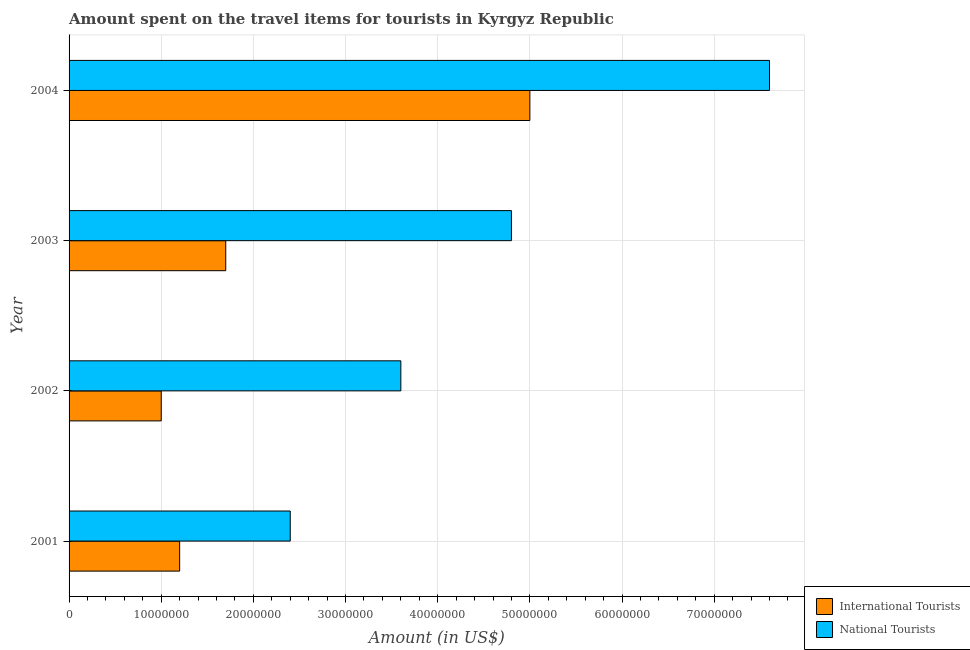How many different coloured bars are there?
Your answer should be compact. 2. How many groups of bars are there?
Keep it short and to the point. 4. Are the number of bars per tick equal to the number of legend labels?
Ensure brevity in your answer.  Yes. How many bars are there on the 1st tick from the bottom?
Your answer should be compact. 2. What is the label of the 4th group of bars from the top?
Provide a short and direct response. 2001. What is the amount spent on travel items of international tourists in 2002?
Make the answer very short. 1.00e+07. Across all years, what is the maximum amount spent on travel items of international tourists?
Provide a short and direct response. 5.00e+07. Across all years, what is the minimum amount spent on travel items of international tourists?
Offer a very short reply. 1.00e+07. In which year was the amount spent on travel items of national tourists maximum?
Provide a short and direct response. 2004. In which year was the amount spent on travel items of national tourists minimum?
Offer a terse response. 2001. What is the total amount spent on travel items of international tourists in the graph?
Your answer should be very brief. 8.90e+07. What is the difference between the amount spent on travel items of national tourists in 2002 and that in 2003?
Offer a very short reply. -1.20e+07. What is the difference between the amount spent on travel items of international tourists in 2002 and the amount spent on travel items of national tourists in 2001?
Offer a very short reply. -1.40e+07. What is the average amount spent on travel items of international tourists per year?
Ensure brevity in your answer.  2.22e+07. In the year 2004, what is the difference between the amount spent on travel items of national tourists and amount spent on travel items of international tourists?
Make the answer very short. 2.60e+07. What is the ratio of the amount spent on travel items of national tourists in 2001 to that in 2004?
Make the answer very short. 0.32. Is the difference between the amount spent on travel items of international tourists in 2003 and 2004 greater than the difference between the amount spent on travel items of national tourists in 2003 and 2004?
Your response must be concise. No. What is the difference between the highest and the second highest amount spent on travel items of national tourists?
Offer a terse response. 2.80e+07. What is the difference between the highest and the lowest amount spent on travel items of national tourists?
Your response must be concise. 5.20e+07. In how many years, is the amount spent on travel items of national tourists greater than the average amount spent on travel items of national tourists taken over all years?
Ensure brevity in your answer.  2. What does the 1st bar from the top in 2003 represents?
Offer a terse response. National Tourists. What does the 2nd bar from the bottom in 2003 represents?
Your answer should be very brief. National Tourists. Are all the bars in the graph horizontal?
Offer a terse response. Yes. What is the difference between two consecutive major ticks on the X-axis?
Your answer should be compact. 1.00e+07. Are the values on the major ticks of X-axis written in scientific E-notation?
Offer a very short reply. No. Does the graph contain any zero values?
Provide a succinct answer. No. Does the graph contain grids?
Offer a terse response. Yes. How are the legend labels stacked?
Keep it short and to the point. Vertical. What is the title of the graph?
Ensure brevity in your answer.  Amount spent on the travel items for tourists in Kyrgyz Republic. What is the label or title of the X-axis?
Provide a succinct answer. Amount (in US$). What is the label or title of the Y-axis?
Offer a very short reply. Year. What is the Amount (in US$) of International Tourists in 2001?
Your answer should be very brief. 1.20e+07. What is the Amount (in US$) in National Tourists in 2001?
Your answer should be compact. 2.40e+07. What is the Amount (in US$) of National Tourists in 2002?
Keep it short and to the point. 3.60e+07. What is the Amount (in US$) of International Tourists in 2003?
Offer a terse response. 1.70e+07. What is the Amount (in US$) of National Tourists in 2003?
Provide a succinct answer. 4.80e+07. What is the Amount (in US$) of National Tourists in 2004?
Your response must be concise. 7.60e+07. Across all years, what is the maximum Amount (in US$) of International Tourists?
Your response must be concise. 5.00e+07. Across all years, what is the maximum Amount (in US$) in National Tourists?
Provide a succinct answer. 7.60e+07. Across all years, what is the minimum Amount (in US$) in International Tourists?
Keep it short and to the point. 1.00e+07. Across all years, what is the minimum Amount (in US$) of National Tourists?
Your answer should be compact. 2.40e+07. What is the total Amount (in US$) of International Tourists in the graph?
Make the answer very short. 8.90e+07. What is the total Amount (in US$) of National Tourists in the graph?
Ensure brevity in your answer.  1.84e+08. What is the difference between the Amount (in US$) in National Tourists in 2001 and that in 2002?
Your answer should be compact. -1.20e+07. What is the difference between the Amount (in US$) of International Tourists in 2001 and that in 2003?
Your answer should be compact. -5.00e+06. What is the difference between the Amount (in US$) of National Tourists in 2001 and that in 2003?
Your response must be concise. -2.40e+07. What is the difference between the Amount (in US$) in International Tourists in 2001 and that in 2004?
Give a very brief answer. -3.80e+07. What is the difference between the Amount (in US$) of National Tourists in 2001 and that in 2004?
Offer a terse response. -5.20e+07. What is the difference between the Amount (in US$) in International Tourists in 2002 and that in 2003?
Your answer should be very brief. -7.00e+06. What is the difference between the Amount (in US$) of National Tourists in 2002 and that in 2003?
Your response must be concise. -1.20e+07. What is the difference between the Amount (in US$) of International Tourists in 2002 and that in 2004?
Your answer should be very brief. -4.00e+07. What is the difference between the Amount (in US$) of National Tourists in 2002 and that in 2004?
Provide a short and direct response. -4.00e+07. What is the difference between the Amount (in US$) of International Tourists in 2003 and that in 2004?
Offer a very short reply. -3.30e+07. What is the difference between the Amount (in US$) of National Tourists in 2003 and that in 2004?
Make the answer very short. -2.80e+07. What is the difference between the Amount (in US$) in International Tourists in 2001 and the Amount (in US$) in National Tourists in 2002?
Provide a short and direct response. -2.40e+07. What is the difference between the Amount (in US$) of International Tourists in 2001 and the Amount (in US$) of National Tourists in 2003?
Keep it short and to the point. -3.60e+07. What is the difference between the Amount (in US$) of International Tourists in 2001 and the Amount (in US$) of National Tourists in 2004?
Keep it short and to the point. -6.40e+07. What is the difference between the Amount (in US$) of International Tourists in 2002 and the Amount (in US$) of National Tourists in 2003?
Make the answer very short. -3.80e+07. What is the difference between the Amount (in US$) of International Tourists in 2002 and the Amount (in US$) of National Tourists in 2004?
Your response must be concise. -6.60e+07. What is the difference between the Amount (in US$) in International Tourists in 2003 and the Amount (in US$) in National Tourists in 2004?
Give a very brief answer. -5.90e+07. What is the average Amount (in US$) of International Tourists per year?
Offer a terse response. 2.22e+07. What is the average Amount (in US$) of National Tourists per year?
Your answer should be compact. 4.60e+07. In the year 2001, what is the difference between the Amount (in US$) in International Tourists and Amount (in US$) in National Tourists?
Ensure brevity in your answer.  -1.20e+07. In the year 2002, what is the difference between the Amount (in US$) of International Tourists and Amount (in US$) of National Tourists?
Provide a succinct answer. -2.60e+07. In the year 2003, what is the difference between the Amount (in US$) in International Tourists and Amount (in US$) in National Tourists?
Your answer should be compact. -3.10e+07. In the year 2004, what is the difference between the Amount (in US$) in International Tourists and Amount (in US$) in National Tourists?
Offer a very short reply. -2.60e+07. What is the ratio of the Amount (in US$) in International Tourists in 2001 to that in 2003?
Your answer should be compact. 0.71. What is the ratio of the Amount (in US$) of National Tourists in 2001 to that in 2003?
Keep it short and to the point. 0.5. What is the ratio of the Amount (in US$) in International Tourists in 2001 to that in 2004?
Make the answer very short. 0.24. What is the ratio of the Amount (in US$) in National Tourists in 2001 to that in 2004?
Offer a terse response. 0.32. What is the ratio of the Amount (in US$) of International Tourists in 2002 to that in 2003?
Keep it short and to the point. 0.59. What is the ratio of the Amount (in US$) in International Tourists in 2002 to that in 2004?
Provide a short and direct response. 0.2. What is the ratio of the Amount (in US$) in National Tourists in 2002 to that in 2004?
Offer a very short reply. 0.47. What is the ratio of the Amount (in US$) in International Tourists in 2003 to that in 2004?
Make the answer very short. 0.34. What is the ratio of the Amount (in US$) in National Tourists in 2003 to that in 2004?
Keep it short and to the point. 0.63. What is the difference between the highest and the second highest Amount (in US$) in International Tourists?
Give a very brief answer. 3.30e+07. What is the difference between the highest and the second highest Amount (in US$) of National Tourists?
Offer a terse response. 2.80e+07. What is the difference between the highest and the lowest Amount (in US$) of International Tourists?
Provide a succinct answer. 4.00e+07. What is the difference between the highest and the lowest Amount (in US$) in National Tourists?
Ensure brevity in your answer.  5.20e+07. 